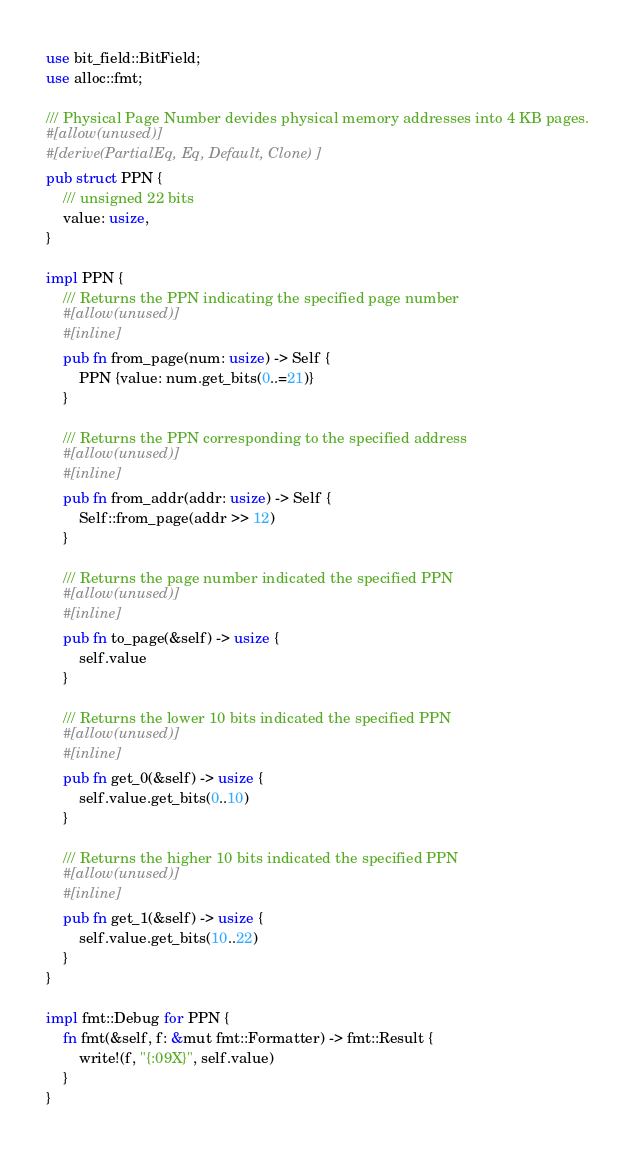<code> <loc_0><loc_0><loc_500><loc_500><_Rust_>use bit_field::BitField;
use alloc::fmt;

/// Physical Page Number devides physical memory addresses into 4 KB pages.
#[allow(unused)]
#[derive(PartialEq, Eq, Default, Clone)]
pub struct PPN {
    /// unsigned 22 bits
    value: usize,
}

impl PPN {
    /// Returns the PPN indicating the specified page number
    #[allow(unused)]
    #[inline]
    pub fn from_page(num: usize) -> Self {
        PPN {value: num.get_bits(0..=21)}
    }

    /// Returns the PPN corresponding to the specified address
    #[allow(unused)]
    #[inline]
    pub fn from_addr(addr: usize) -> Self {
        Self::from_page(addr >> 12)
    }

    /// Returns the page number indicated the specified PPN
    #[allow(unused)]
    #[inline]
    pub fn to_page(&self) -> usize {
        self.value
    }

    /// Returns the lower 10 bits indicated the specified PPN
    #[allow(unused)]
    #[inline]
    pub fn get_0(&self) -> usize {
        self.value.get_bits(0..10)
    }

    /// Returns the higher 10 bits indicated the specified PPN
    #[allow(unused)]
    #[inline]
    pub fn get_1(&self) -> usize {
        self.value.get_bits(10..22)
    }
}

impl fmt::Debug for PPN {
    fn fmt(&self, f: &mut fmt::Formatter) -> fmt::Result {
        write!(f, "{:09X}", self.value)
    }
}</code> 